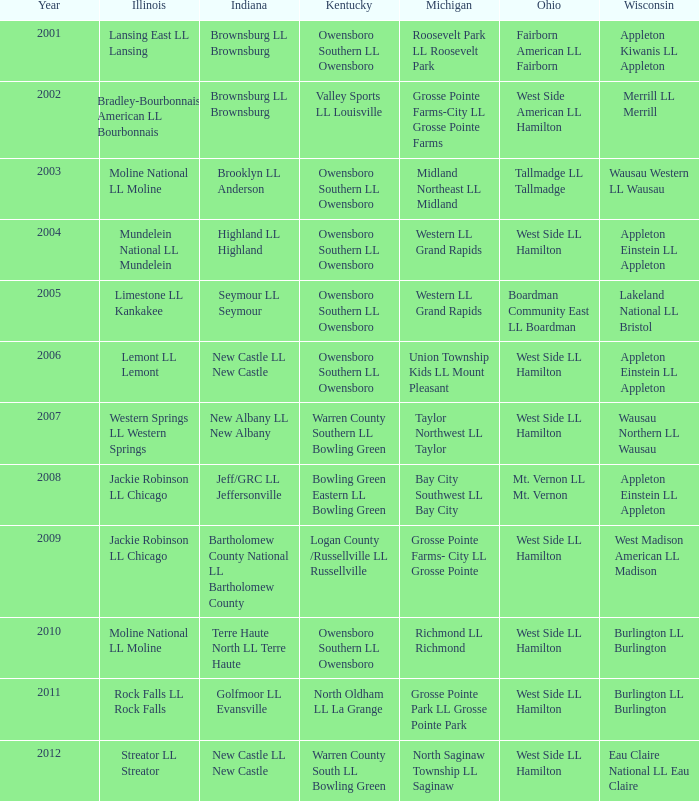What was the small league team in michigan when the small league team in indiana was terre haute north ll terre haute? Richmond LL Richmond. 